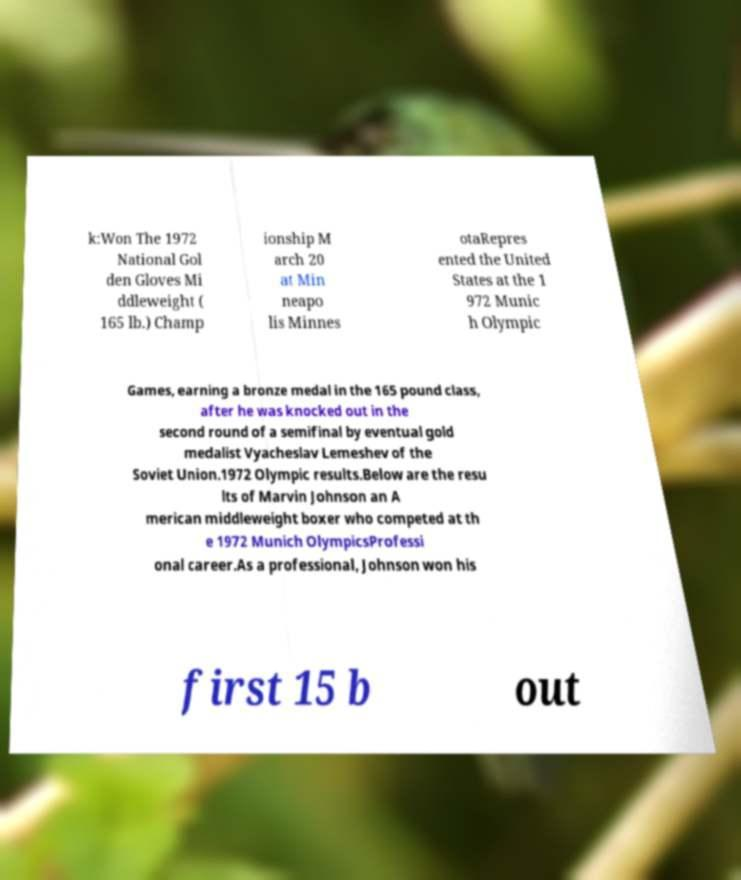Can you accurately transcribe the text from the provided image for me? k:Won The 1972 National Gol den Gloves Mi ddleweight ( 165 lb.) Champ ionship M arch 20 at Min neapo lis Minnes otaRepres ented the United States at the 1 972 Munic h Olympic Games, earning a bronze medal in the 165 pound class, after he was knocked out in the second round of a semifinal by eventual gold medalist Vyacheslav Lemeshev of the Soviet Union.1972 Olympic results.Below are the resu lts of Marvin Johnson an A merican middleweight boxer who competed at th e 1972 Munich OlympicsProfessi onal career.As a professional, Johnson won his first 15 b out 